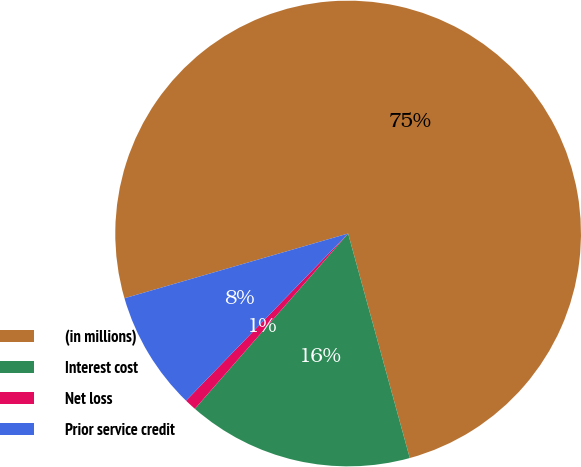Convert chart. <chart><loc_0><loc_0><loc_500><loc_500><pie_chart><fcel>(in millions)<fcel>Interest cost<fcel>Net loss<fcel>Prior service credit<nl><fcel>75.22%<fcel>15.7%<fcel>0.82%<fcel>8.26%<nl></chart> 